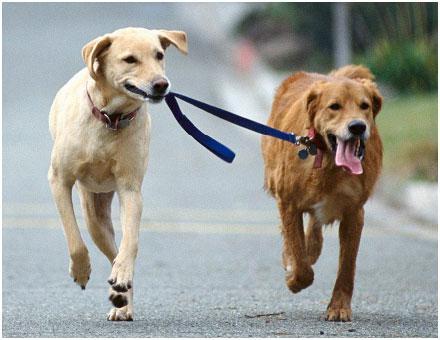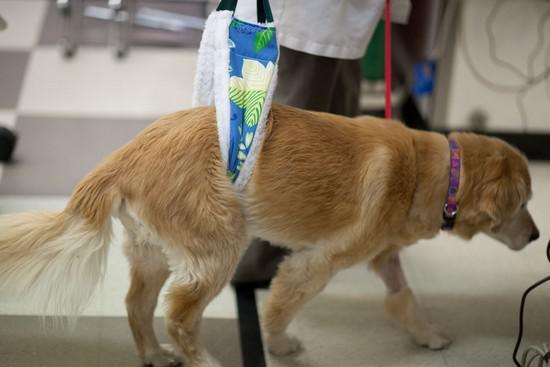The first image is the image on the left, the second image is the image on the right. Evaluate the accuracy of this statement regarding the images: "There is a dog sitting on a grassy lawn". Is it true? Answer yes or no. No. The first image is the image on the left, the second image is the image on the right. Evaluate the accuracy of this statement regarding the images: "No dogs have dark fur, one dog is standing on all fours, and at least one dog wears a collar.". Is it true? Answer yes or no. Yes. 